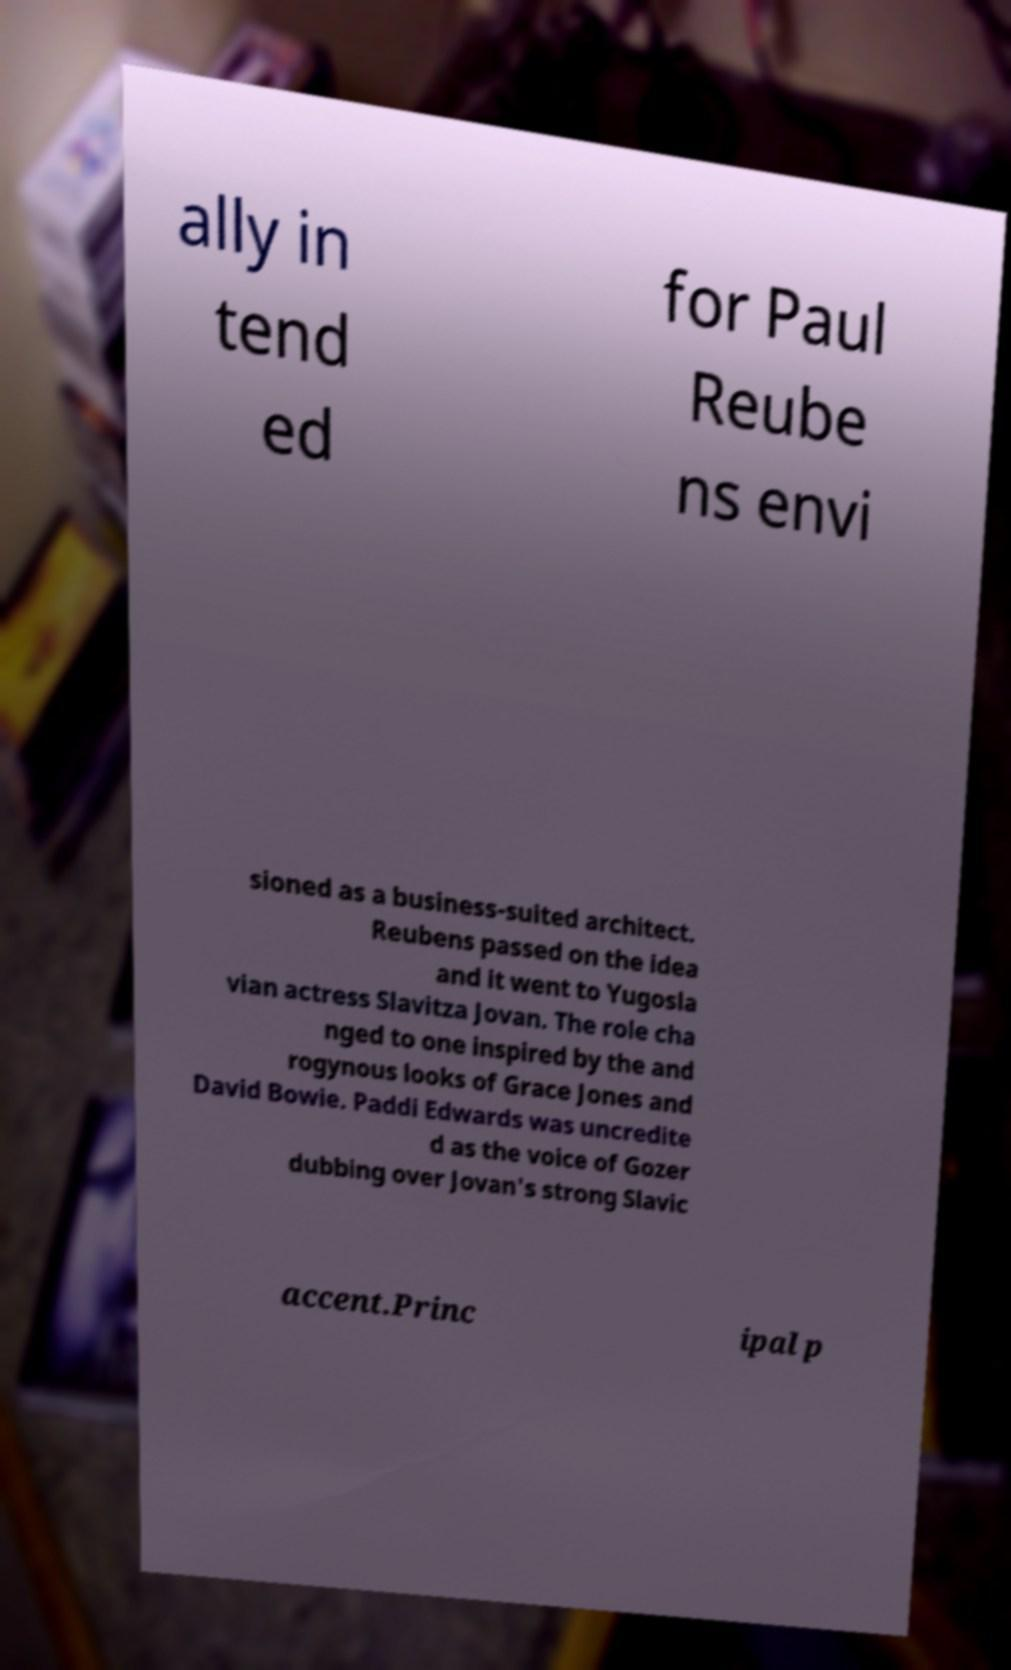Can you accurately transcribe the text from the provided image for me? ally in tend ed for Paul Reube ns envi sioned as a business-suited architect. Reubens passed on the idea and it went to Yugosla vian actress Slavitza Jovan. The role cha nged to one inspired by the and rogynous looks of Grace Jones and David Bowie. Paddi Edwards was uncredite d as the voice of Gozer dubbing over Jovan's strong Slavic accent.Princ ipal p 